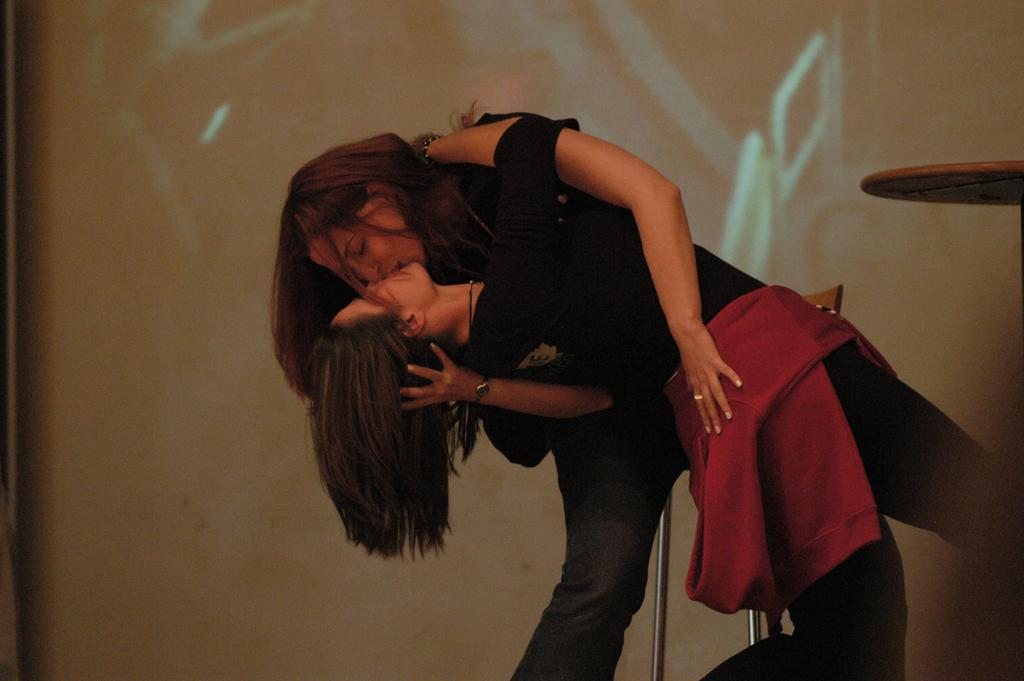How many people are in the image? There are two people in the image. What colors are the dresses of the people in the image? One person is wearing a black dress, and the other person is wearing a red dress. What is located to the right of the people in the image? There is a table to the right of the people in the image. What can be seen in the background of the image? There is a screen in the background of the image. What type of ice can be seen melting on the table in the image? There is no ice present on the table in the image. What message is displayed on the sign behind the people in the image? There is no sign present behind the people in the image. 